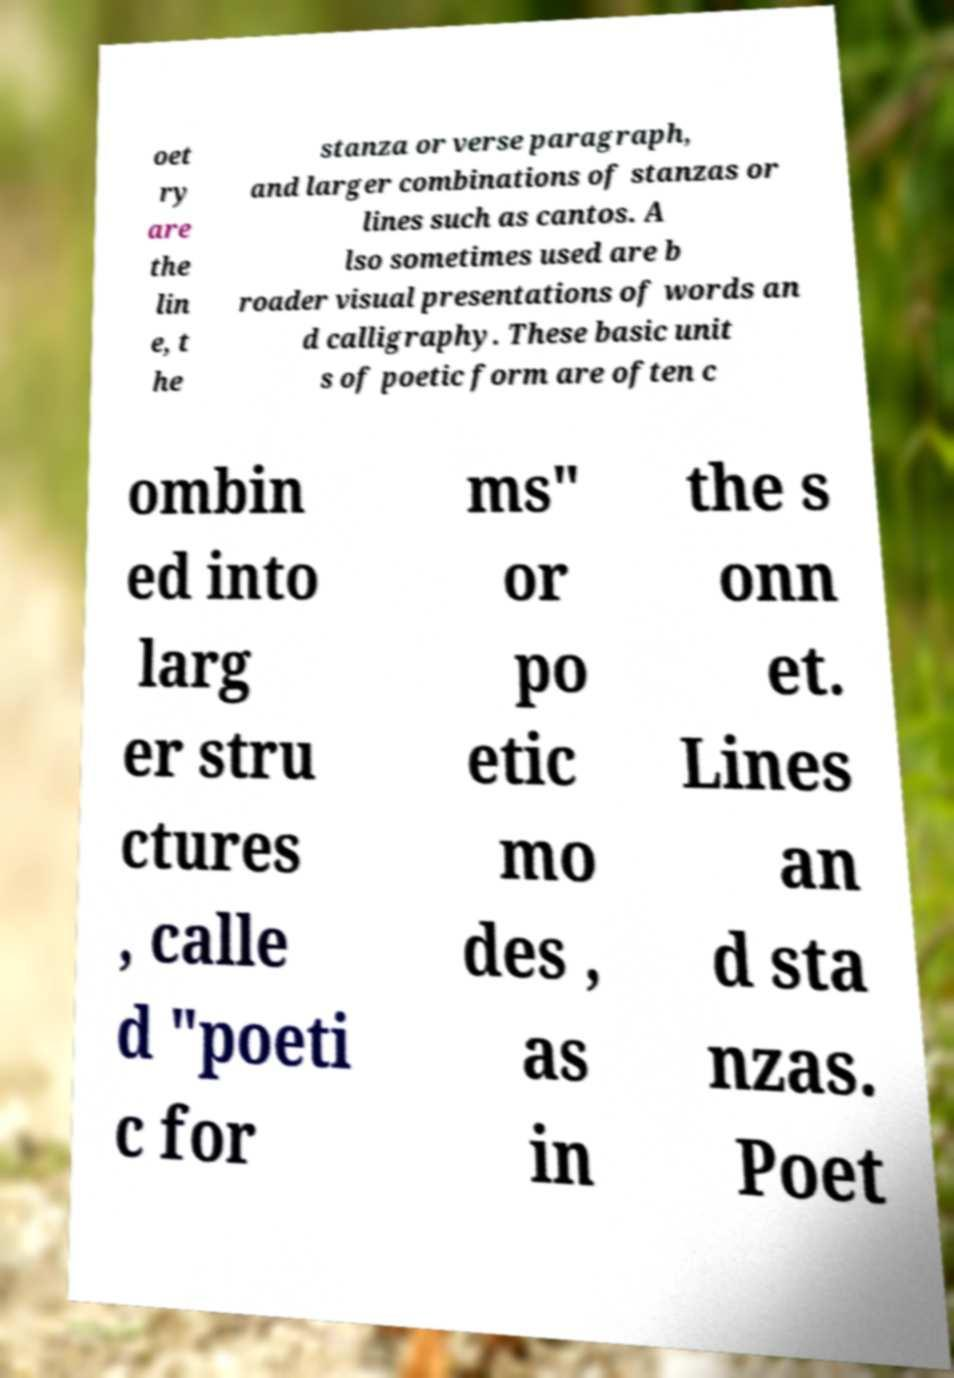Please identify and transcribe the text found in this image. oet ry are the lin e, t he stanza or verse paragraph, and larger combinations of stanzas or lines such as cantos. A lso sometimes used are b roader visual presentations of words an d calligraphy. These basic unit s of poetic form are often c ombin ed into larg er stru ctures , calle d "poeti c for ms" or po etic mo des , as in the s onn et. Lines an d sta nzas. Poet 